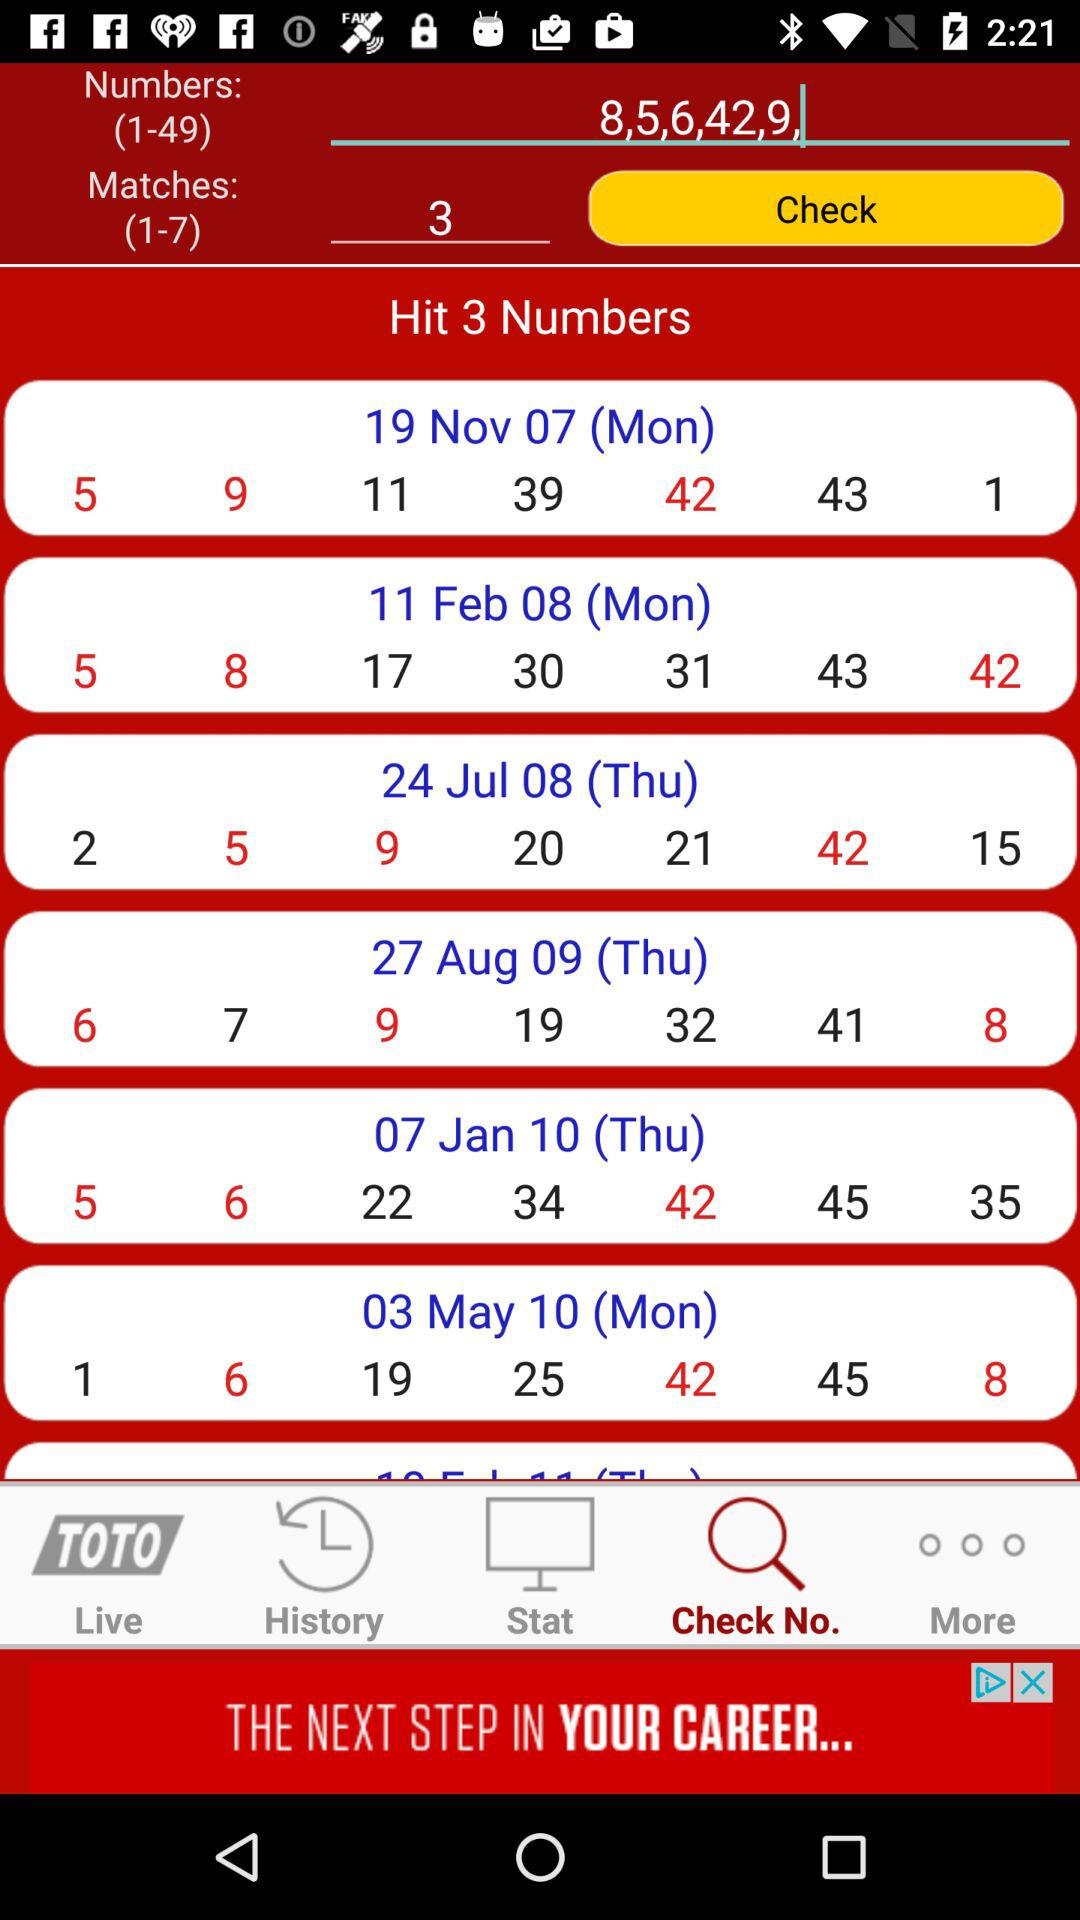What is the range of "Numbers"? The range is 1-49. 